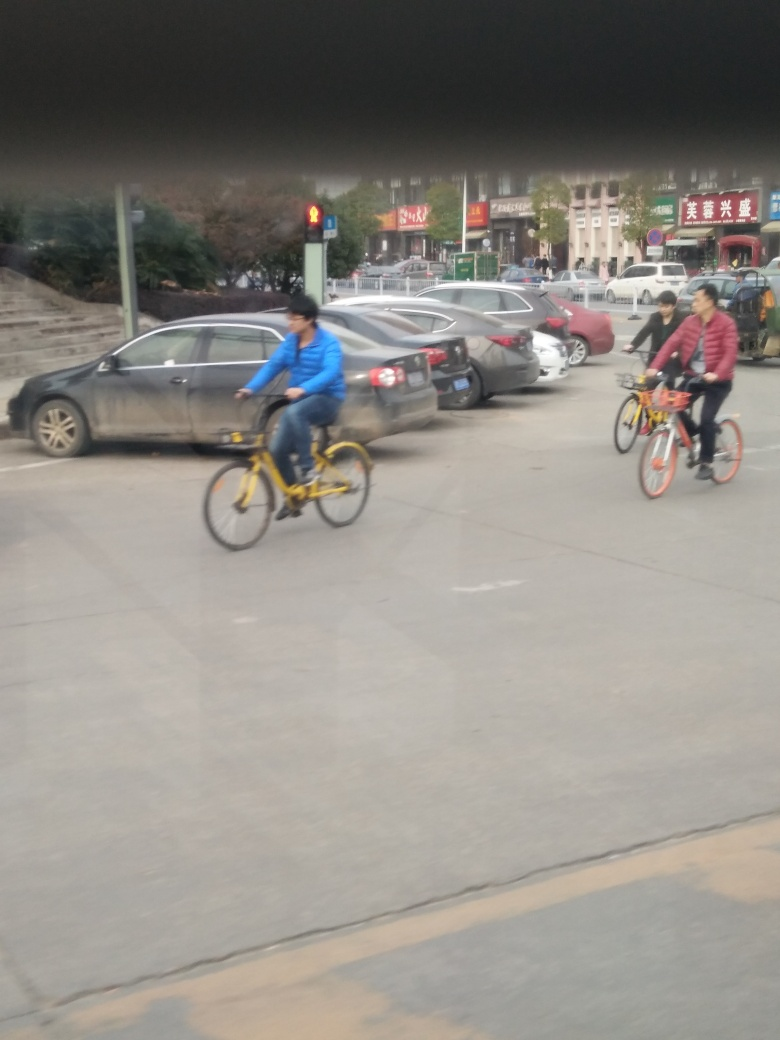Can you comment on the safety of the cyclists? Based on the image, the cyclists are not wearing helmets, which can be a safety concern. Additionally, one cyclist appears to be crossing against the traffic signal, which is a safety risk. 